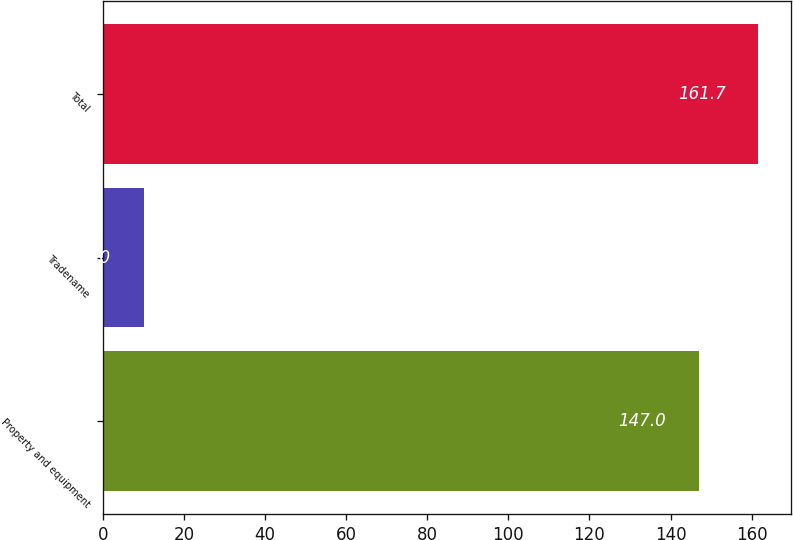Convert chart to OTSL. <chart><loc_0><loc_0><loc_500><loc_500><bar_chart><fcel>Property and equipment<fcel>Tradename<fcel>Total<nl><fcel>147<fcel>10<fcel>161.7<nl></chart> 